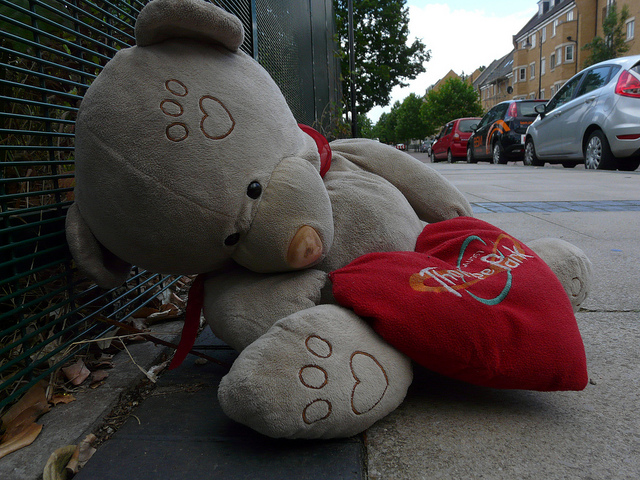<image>What word is readable in the photo? It is ambiguous. The word might be 'park' or there is no readable word in the photo. What word is readable in the photo? There is no word readable in the photo. 